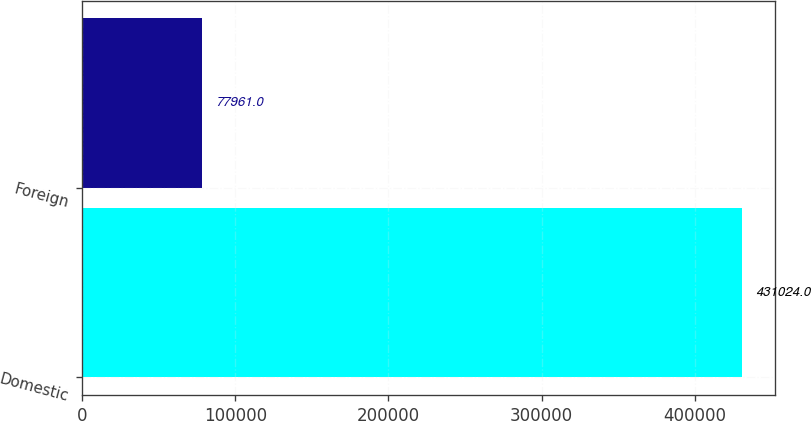<chart> <loc_0><loc_0><loc_500><loc_500><bar_chart><fcel>Domestic<fcel>Foreign<nl><fcel>431024<fcel>77961<nl></chart> 